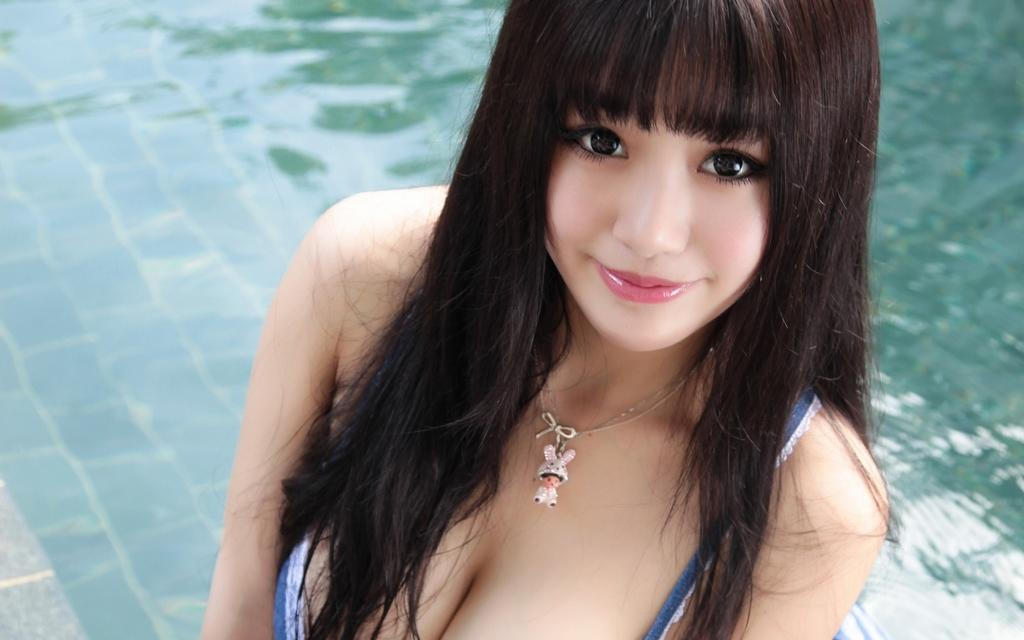Who or what is the main subject in the image? There is a person in the image. Can you describe the person's attire? The person is wearing a blue and white dress. What can be seen in the background of the image? There is water visible in the background of the image. What is the reflection of in the water? The reflection of trees is visible in the water. What type of food is being prepared by the person in the image? There is no indication in the image that the person is preparing food, so it cannot be determined from the picture. 